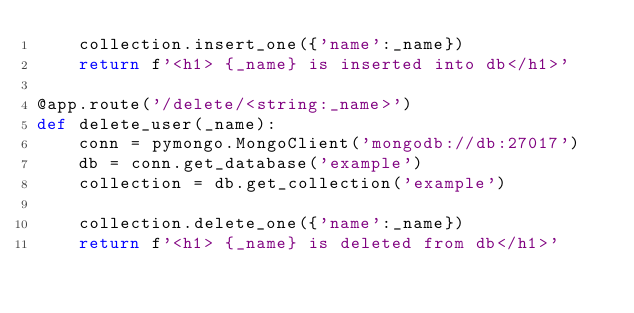Convert code to text. <code><loc_0><loc_0><loc_500><loc_500><_Python_>	collection.insert_one({'name':_name})
	return f'<h1> {_name} is inserted into db</h1>'	

@app.route('/delete/<string:_name>') 
def delete_user(_name):
	conn = pymongo.MongoClient('mongodb://db:27017')
	db = conn.get_database('example')
	collection = db.get_collection('example')

	collection.delete_one({'name':_name})
	return f'<h1> {_name} is deleted from db</h1>'	
</code> 